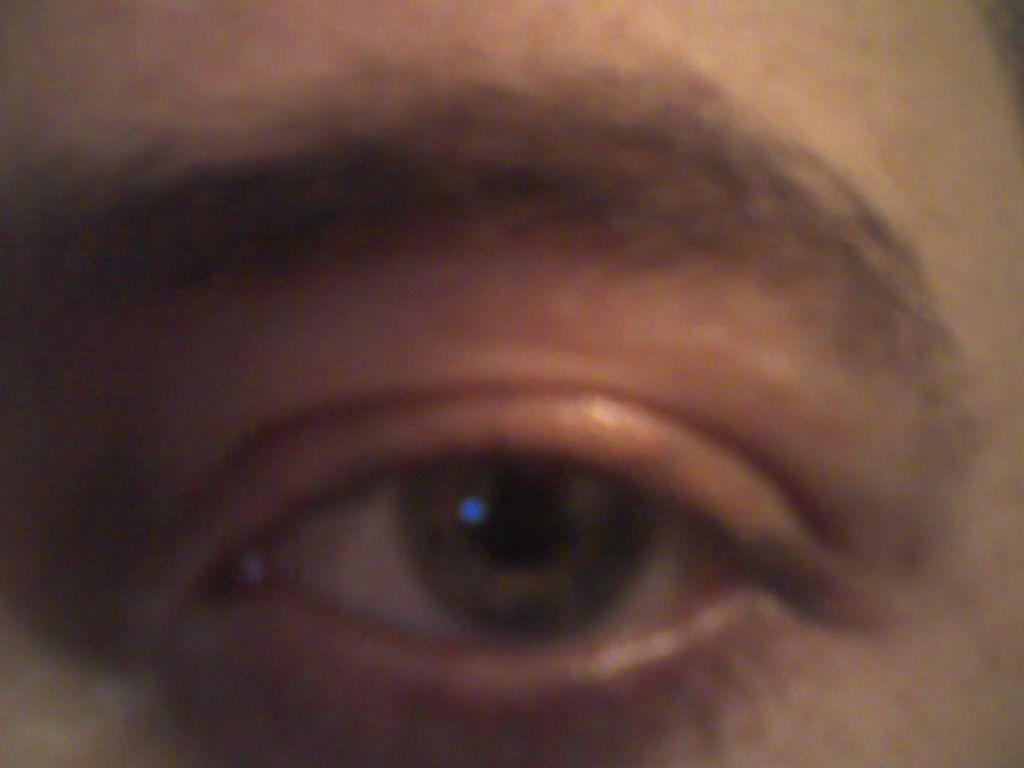What is the main subject of the image? The main subject of the image is a human eye. What other facial feature is visible in the image? There is an eyebrow in the image. How many fish can be seen swimming in the drawer in the image? There are no fish or drawers present in the image; it features a human eye and an eyebrow. 